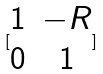<formula> <loc_0><loc_0><loc_500><loc_500>[ \begin{matrix} 1 & - R \\ 0 & 1 \end{matrix} ]</formula> 